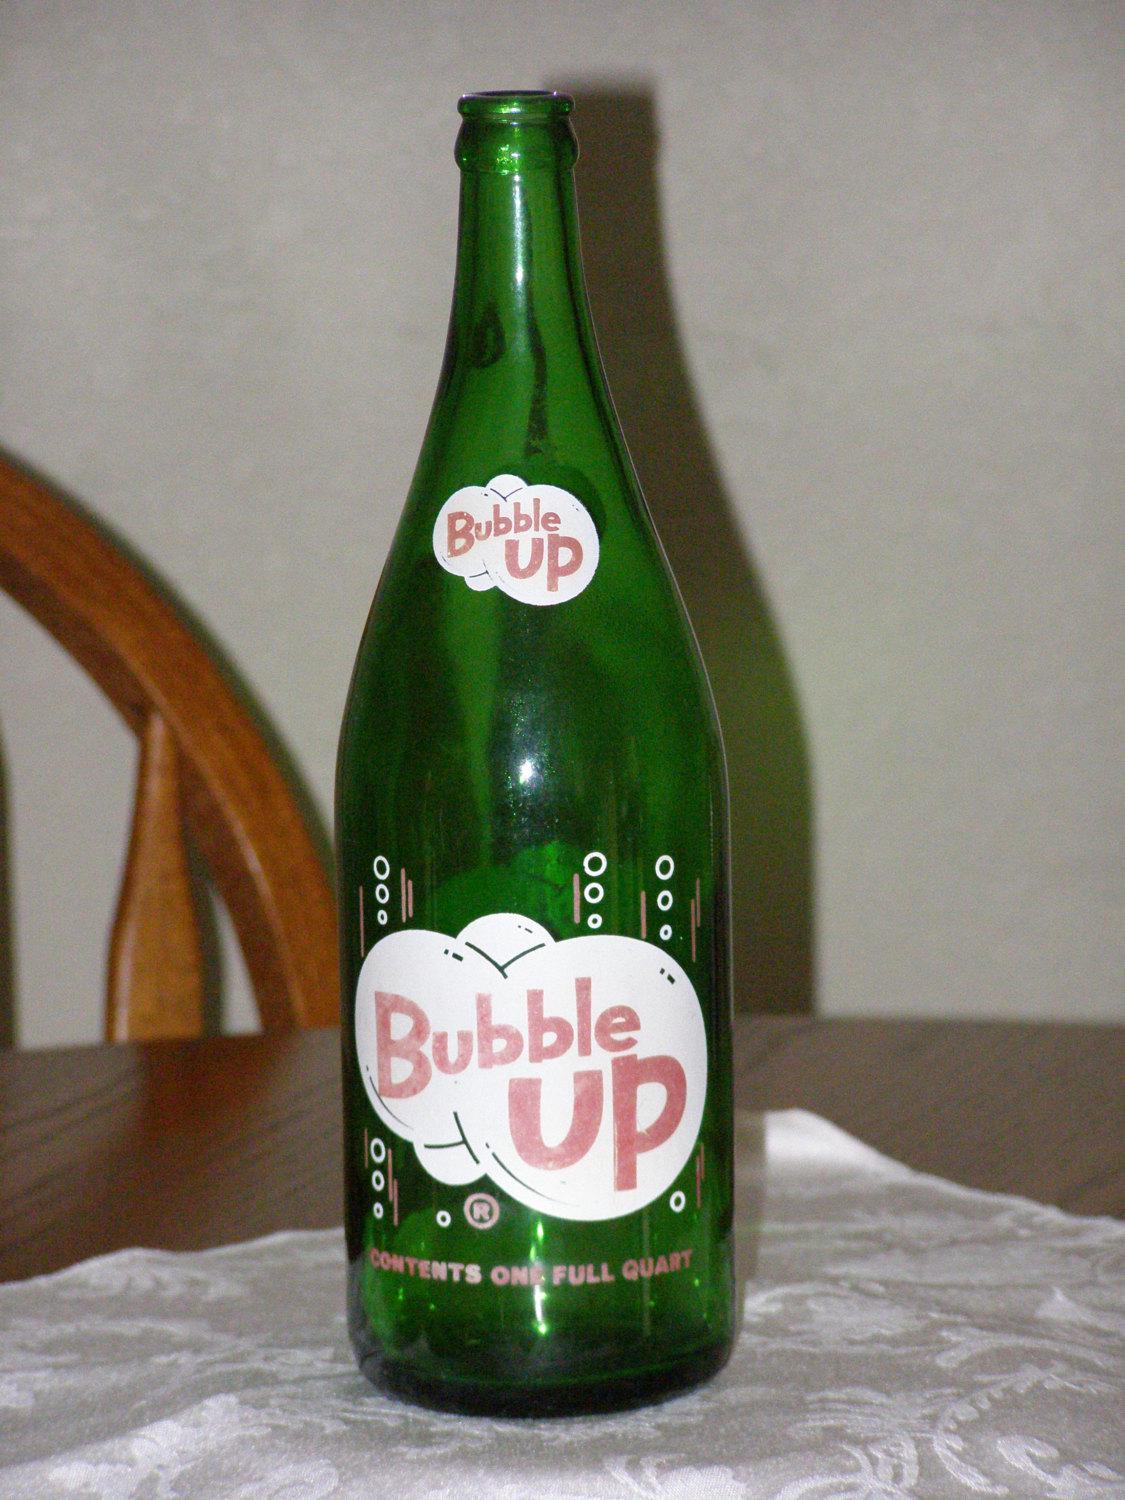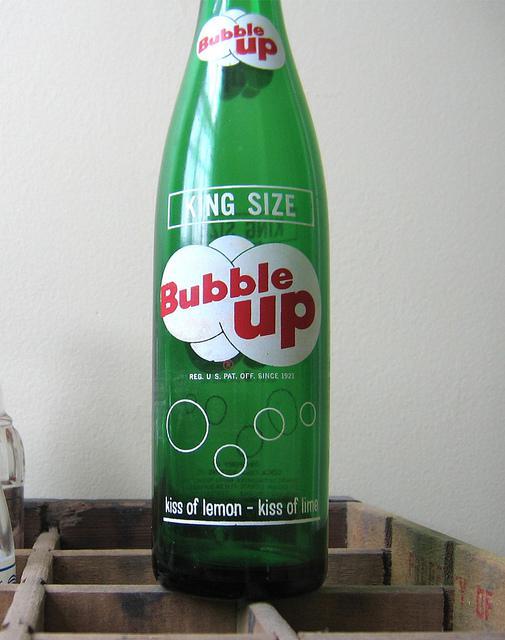The first image is the image on the left, the second image is the image on the right. Evaluate the accuracy of this statement regarding the images: "Each image contains a single green glass soda bottle, and at least one bottle depicted has overlapping white circle shapes on its front.". Is it true? Answer yes or no. Yes. The first image is the image on the left, the second image is the image on the right. Assess this claim about the two images: "Has atleast one picture of a drink that isn't Bubble Up". Correct or not? Answer yes or no. No. 